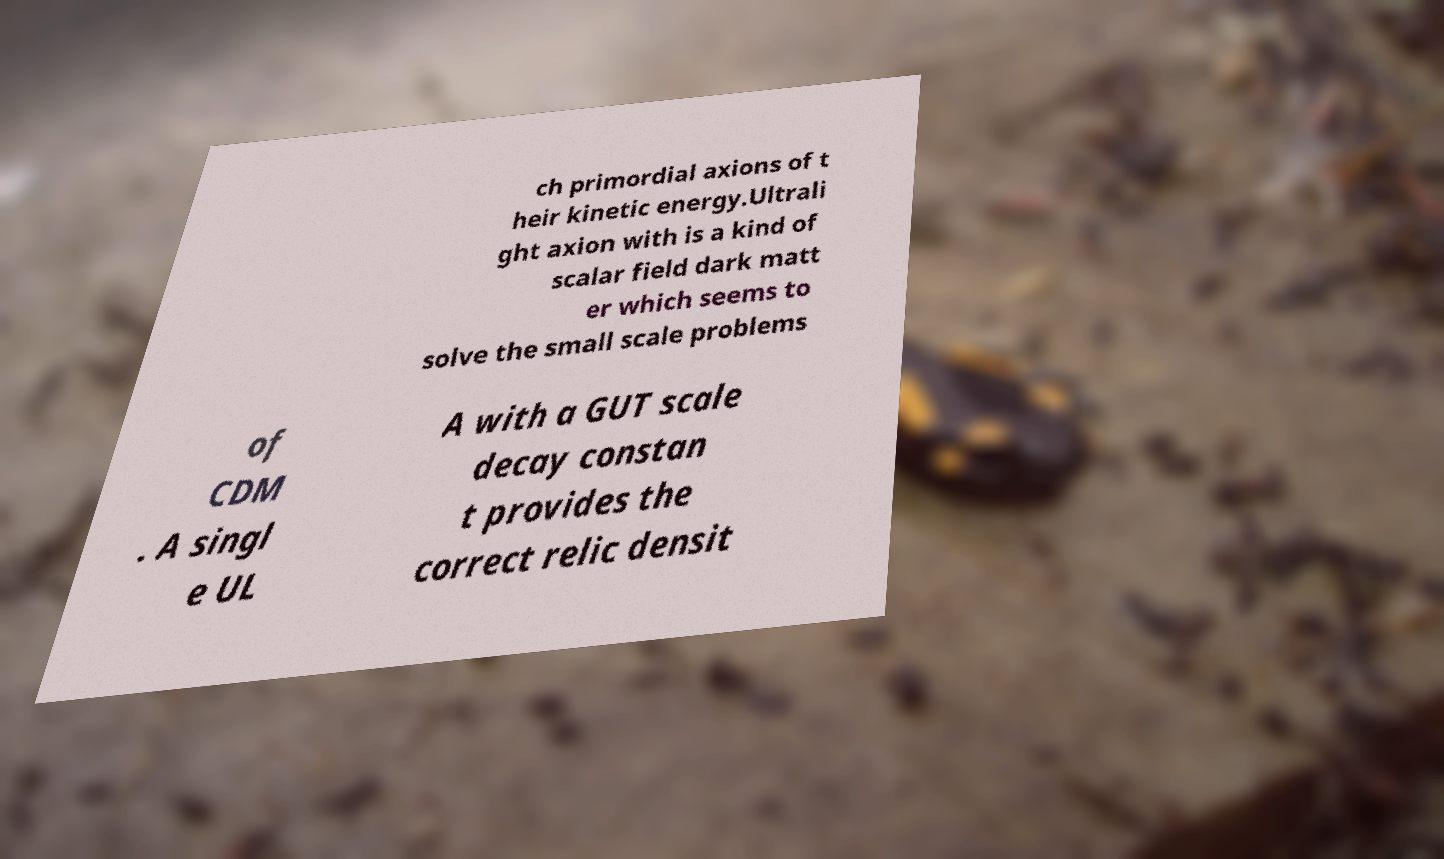Please identify and transcribe the text found in this image. ch primordial axions of t heir kinetic energy.Ultrali ght axion with is a kind of scalar field dark matt er which seems to solve the small scale problems of CDM . A singl e UL A with a GUT scale decay constan t provides the correct relic densit 